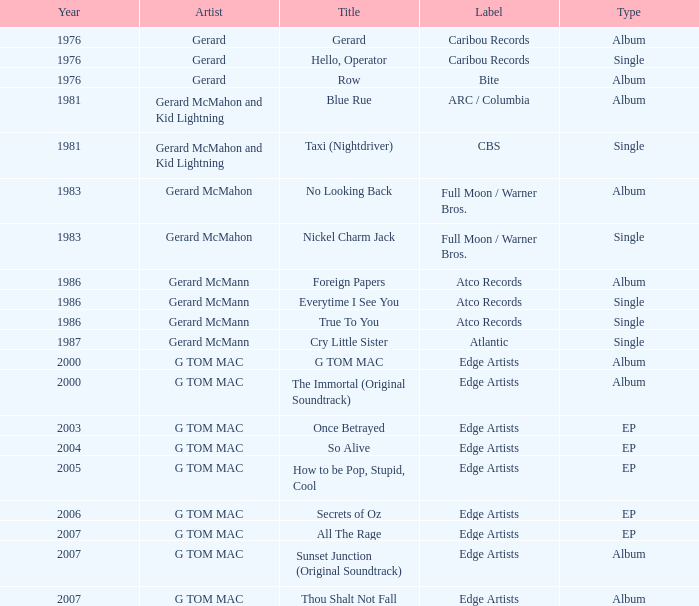Which title possesses a type of ep and a year greater than 2003? So Alive, How to be Pop, Stupid, Cool, Secrets of Oz, All The Rage. 